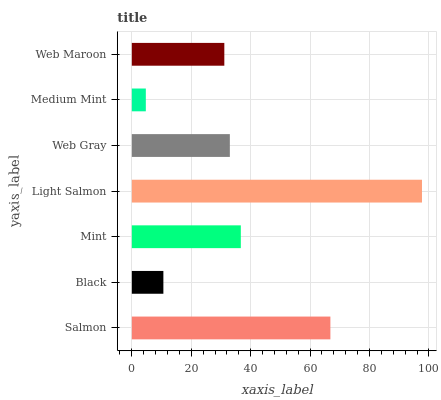Is Medium Mint the minimum?
Answer yes or no. Yes. Is Light Salmon the maximum?
Answer yes or no. Yes. Is Black the minimum?
Answer yes or no. No. Is Black the maximum?
Answer yes or no. No. Is Salmon greater than Black?
Answer yes or no. Yes. Is Black less than Salmon?
Answer yes or no. Yes. Is Black greater than Salmon?
Answer yes or no. No. Is Salmon less than Black?
Answer yes or no. No. Is Web Gray the high median?
Answer yes or no. Yes. Is Web Gray the low median?
Answer yes or no. Yes. Is Salmon the high median?
Answer yes or no. No. Is Salmon the low median?
Answer yes or no. No. 